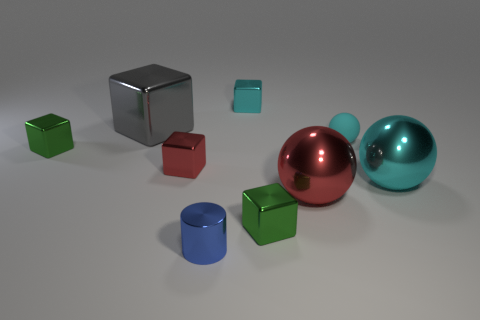Subtract all big shiny cubes. How many cubes are left? 4 Subtract all gray blocks. How many blocks are left? 4 Subtract all purple cubes. Subtract all gray cylinders. How many cubes are left? 5 Subtract all blocks. How many objects are left? 4 Add 4 gray balls. How many gray balls exist? 4 Subtract 0 purple cylinders. How many objects are left? 9 Subtract all tiny red matte things. Subtract all tiny green blocks. How many objects are left? 7 Add 6 cyan balls. How many cyan balls are left? 8 